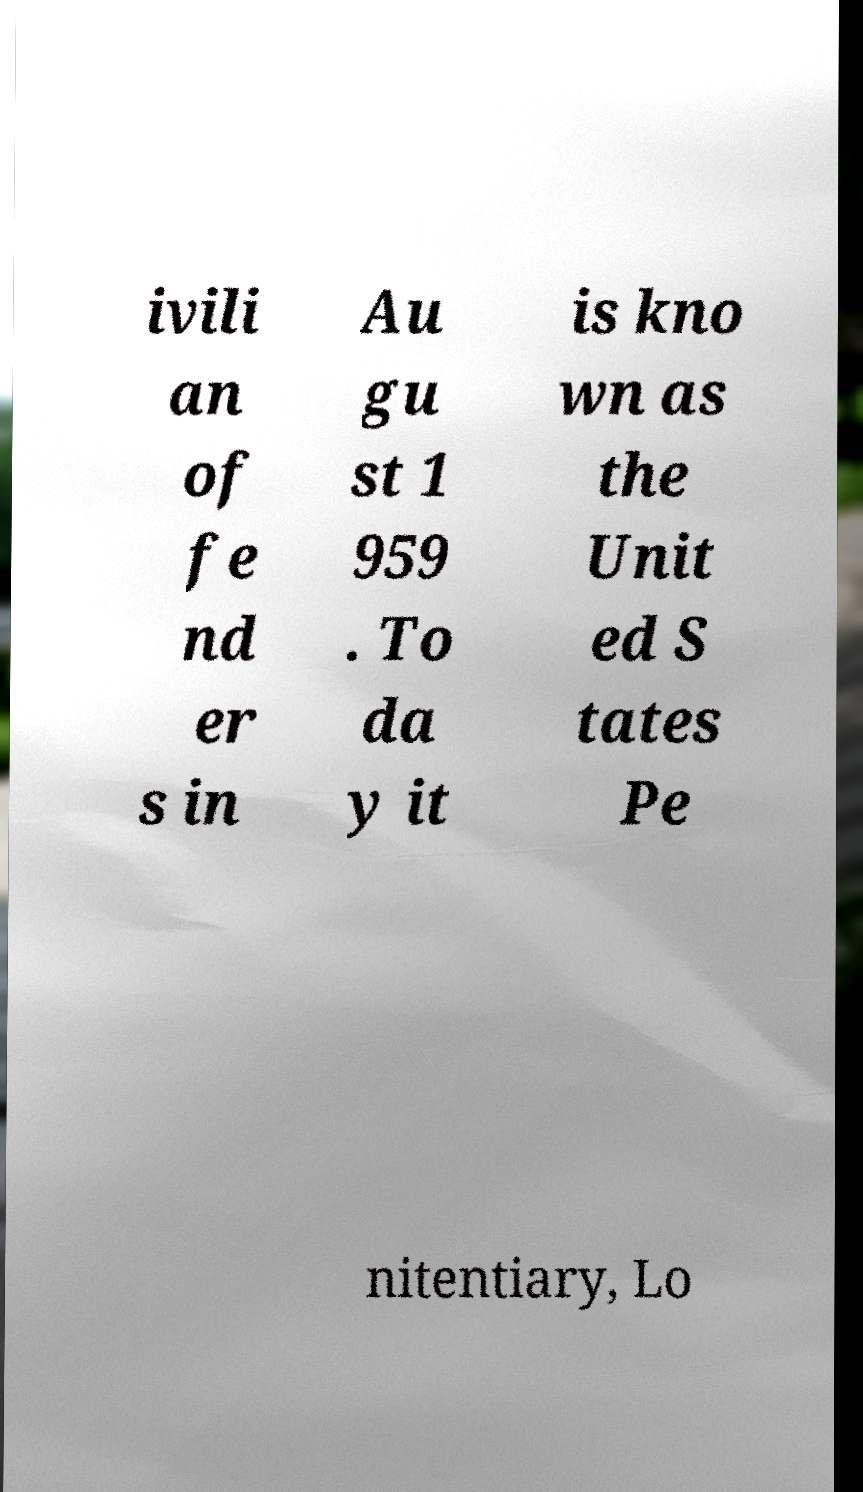Please identify and transcribe the text found in this image. ivili an of fe nd er s in Au gu st 1 959 . To da y it is kno wn as the Unit ed S tates Pe nitentiary, Lo 